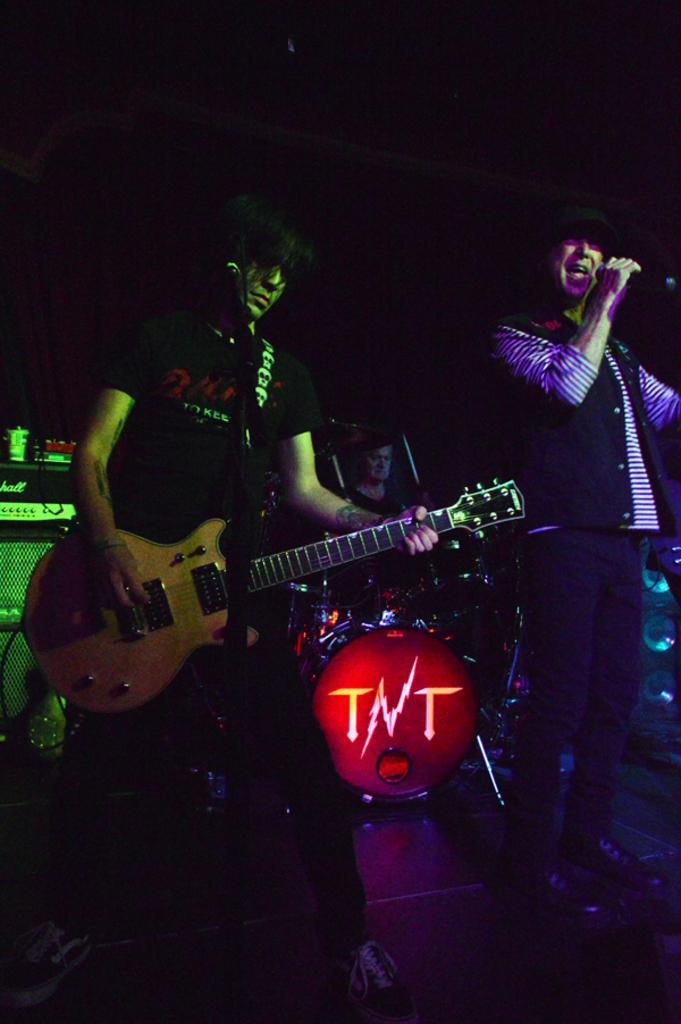Describe this image in one or two sentences. In the image we can see there is a man who is standing and holding guitar in his hand and a person is holding mic in his hand. At the back a man is playing a drum set. 